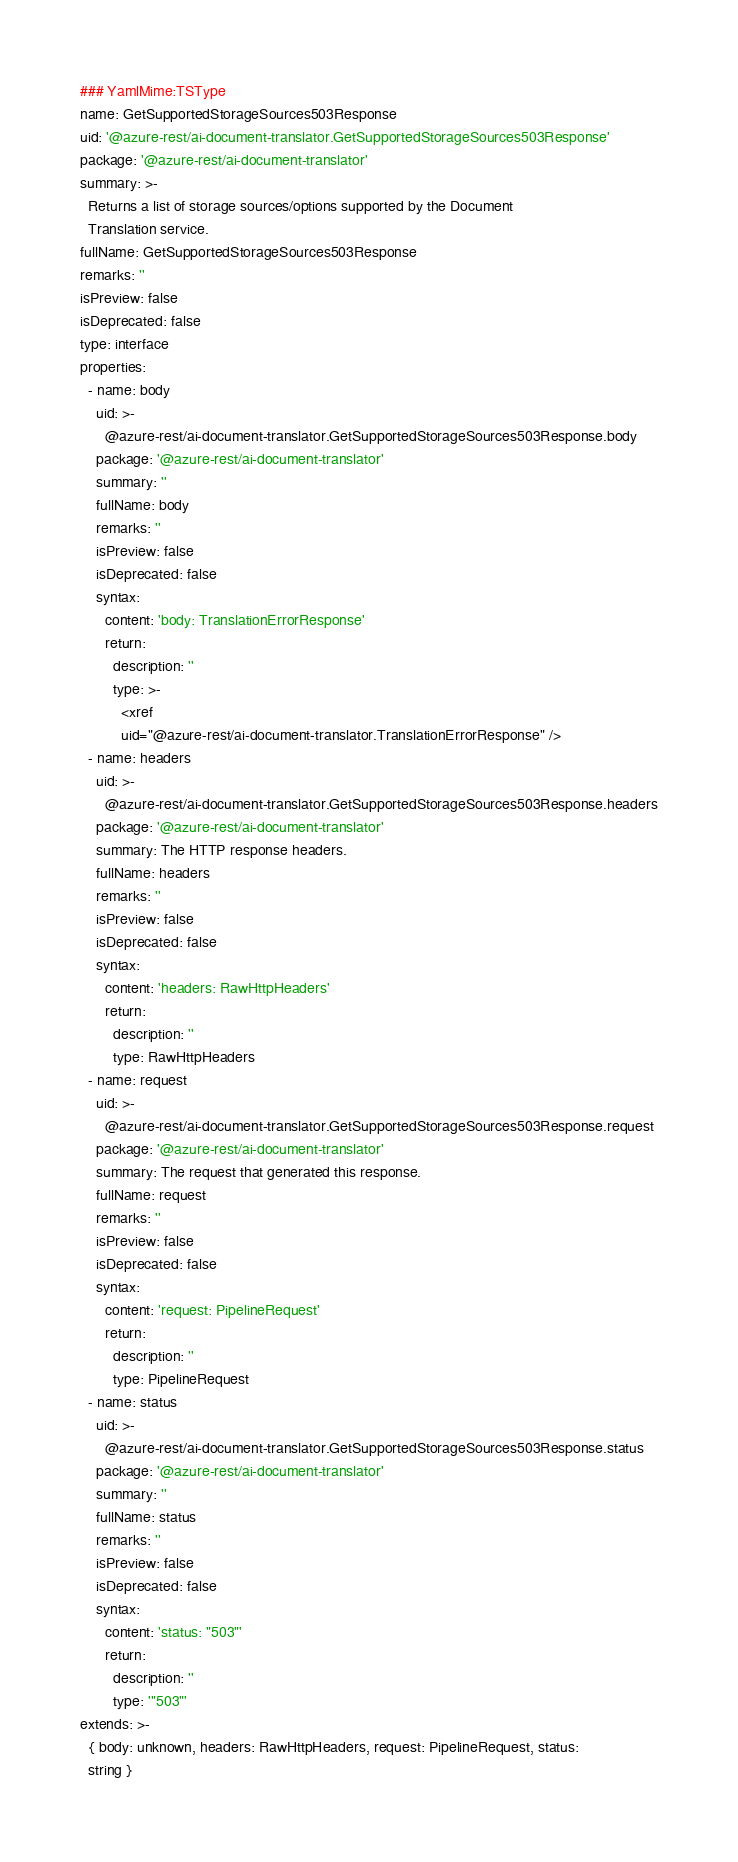<code> <loc_0><loc_0><loc_500><loc_500><_YAML_>### YamlMime:TSType
name: GetSupportedStorageSources503Response
uid: '@azure-rest/ai-document-translator.GetSupportedStorageSources503Response'
package: '@azure-rest/ai-document-translator'
summary: >-
  Returns a list of storage sources/options supported by the Document
  Translation service.
fullName: GetSupportedStorageSources503Response
remarks: ''
isPreview: false
isDeprecated: false
type: interface
properties:
  - name: body
    uid: >-
      @azure-rest/ai-document-translator.GetSupportedStorageSources503Response.body
    package: '@azure-rest/ai-document-translator'
    summary: ''
    fullName: body
    remarks: ''
    isPreview: false
    isDeprecated: false
    syntax:
      content: 'body: TranslationErrorResponse'
      return:
        description: ''
        type: >-
          <xref
          uid="@azure-rest/ai-document-translator.TranslationErrorResponse" />
  - name: headers
    uid: >-
      @azure-rest/ai-document-translator.GetSupportedStorageSources503Response.headers
    package: '@azure-rest/ai-document-translator'
    summary: The HTTP response headers.
    fullName: headers
    remarks: ''
    isPreview: false
    isDeprecated: false
    syntax:
      content: 'headers: RawHttpHeaders'
      return:
        description: ''
        type: RawHttpHeaders
  - name: request
    uid: >-
      @azure-rest/ai-document-translator.GetSupportedStorageSources503Response.request
    package: '@azure-rest/ai-document-translator'
    summary: The request that generated this response.
    fullName: request
    remarks: ''
    isPreview: false
    isDeprecated: false
    syntax:
      content: 'request: PipelineRequest'
      return:
        description: ''
        type: PipelineRequest
  - name: status
    uid: >-
      @azure-rest/ai-document-translator.GetSupportedStorageSources503Response.status
    package: '@azure-rest/ai-document-translator'
    summary: ''
    fullName: status
    remarks: ''
    isPreview: false
    isDeprecated: false
    syntax:
      content: 'status: "503"'
      return:
        description: ''
        type: '"503"'
extends: >-
  { body: unknown, headers: RawHttpHeaders, request: PipelineRequest, status:
  string }
</code> 